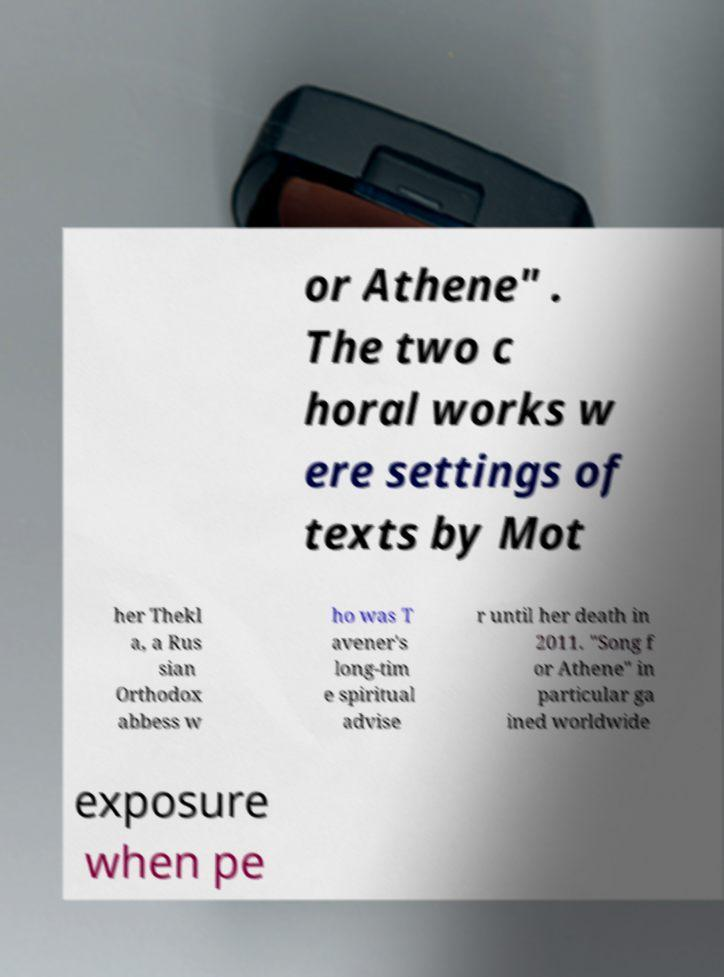For documentation purposes, I need the text within this image transcribed. Could you provide that? or Athene" . The two c horal works w ere settings of texts by Mot her Thekl a, a Rus sian Orthodox abbess w ho was T avener's long-tim e spiritual advise r until her death in 2011. "Song f or Athene" in particular ga ined worldwide exposure when pe 